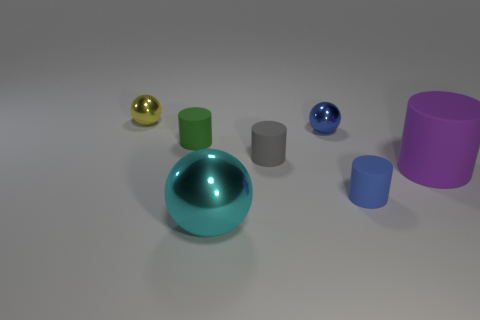Subtract all small gray cylinders. How many cylinders are left? 3 Add 1 tiny cylinders. How many objects exist? 8 Subtract all blue balls. How many balls are left? 2 Subtract 2 cylinders. How many cylinders are left? 2 Add 1 green cylinders. How many green cylinders are left? 2 Add 2 small blue cylinders. How many small blue cylinders exist? 3 Subtract 0 red balls. How many objects are left? 7 Subtract all spheres. How many objects are left? 4 Subtract all yellow spheres. Subtract all green cylinders. How many spheres are left? 2 Subtract all purple spheres. Subtract all tiny green cylinders. How many objects are left? 6 